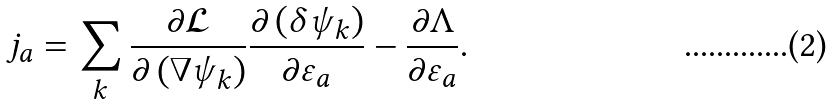<formula> <loc_0><loc_0><loc_500><loc_500>j _ { a } = \sum _ { k } \frac { \partial \mathcal { L } } { \partial \left ( \nabla \psi _ { k } \right ) } \frac { \partial \left ( \delta \psi _ { k } \right ) } { \partial \varepsilon _ { a } } - \frac { \partial \Lambda } { \partial \varepsilon _ { a } } .</formula> 